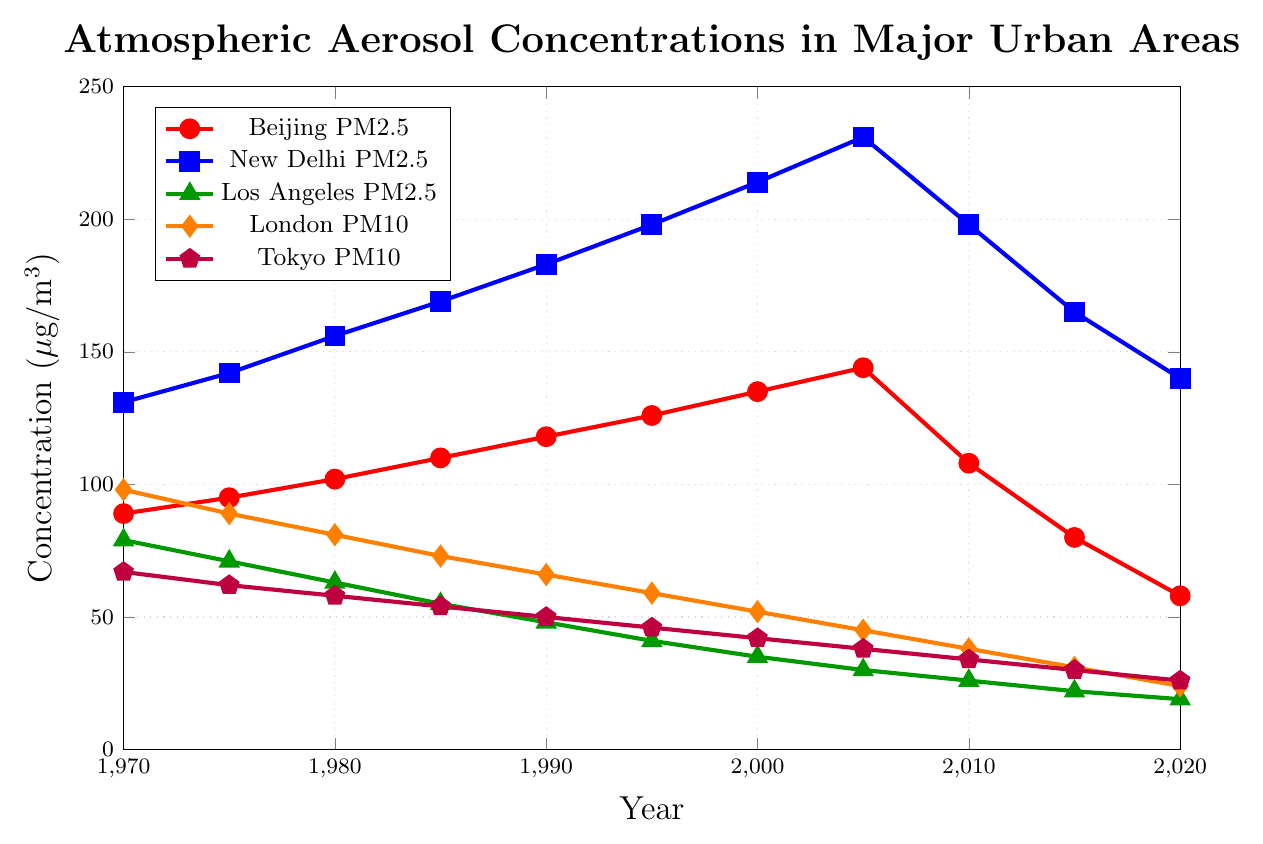what city had the highest PM2.5 levels in 2005? From the figure, we can directly observe the markers and colors representing PM2.5 levels in different cities. New Delhi, indicated by the blue squares, had the highest levels at around 231 µg/m³ in 2005.
Answer: New Delhi How did PM2.5 levels in Beijing change from 2010 to 2020? Observing the red circles representing Beijing PM2.5 levels, we see a decline from approximately 108 µg/m³ in 2010 to 58 µg/m³ in 2020.
Answer: Decreased Which city showed the greatest reduction in PM2.5 levels from 1970 to 2020? Comparing the changes for Beijing (red), New Delhi (blue), and Los Angeles (green), Los Angeles had the greatest reduction, dropping from 79 µg/m³ to 19 µg/m³.
Answer: Los Angeles On average, how did Tokyo's PM10 levels change per decade from 1970 to 2020? First, calculate the change each decade: (62-67), (58-62), (54-58), (50-54), (46-50), (42-46), (38-42), (34-38), (30-34), (26-30). Summing all changes: -5+-4+-4+-4+-4+-4+-4+-4+-4+-4 = -40. Divide by 5 decades, -40/5 = -8 µg/m³ per decade.
Answer: Decreased by 8 µg/m³/decade Which city’s PM2.5 levels saw a sharp decline after 2005? Observing the trends, New Delhi (blue) showed a significant drop from 231 µg/m³ in 2005 to 198 µg/m³ in 2010 and continued declining to 140 µg/m³ by 2020.
Answer: New Delhi What is the difference in PM10 levels between London and Tokyo in 2020? From the figure, London’s PM10 (orange) is at 24 µg/m³ and Tokyo’s PM10 (purple) is at 26 µg/m³. The difference is 26 - 24.
Answer: 2 µg/m³ Did any city experience an increase in PM2.5 levels from 2010 to 2015? Reviewing the data, neither Beijing (red), New Delhi (blue), nor Los Angeles (green) experienced an increase in PM2.5 levels in this period.
Answer: No Which city had a more significant reduction in PM10 levels from 1995 to 2020, London or Tokyo? Examine the downward trend for London from 59 to 24 and for Tokyo from 46 to 26. London had a reduction of 35 µg/m³ versus Tokyo’s 20 µg/m³.
Answer: London Is the difference in PM2.5 levels between Beijing and New Delhi larger in 1970 or 2020? In 1970, the difference is 42 (131-89), and in 2020, it's 82 (140-58).
Answer: 2020 How does the PM2.5 level of Los Angeles in 1990 compare to that of Beijing in 1970? Los Angeles in 1990 had a PM2.5 level of 48 µg/m³, significantly lower than Beijing’s 89 µg/m³ in 1970.
Answer: Lower 